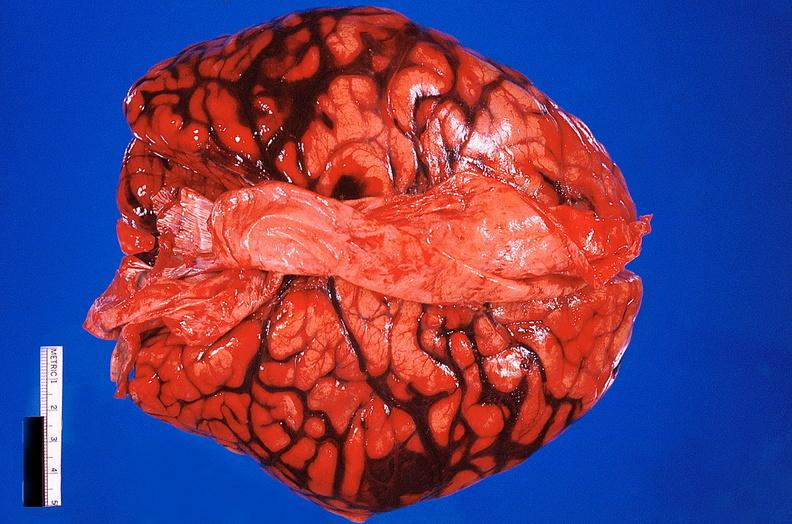what does this image show?
Answer the question using a single word or phrase. Brain 